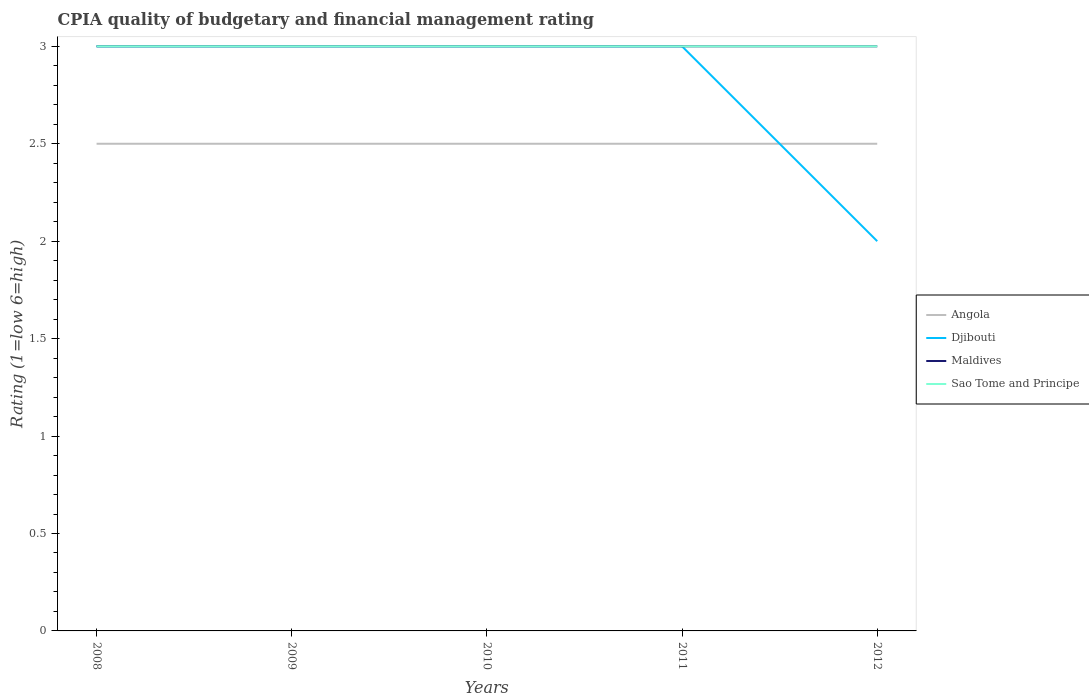How many different coloured lines are there?
Your answer should be compact. 4. Does the line corresponding to Angola intersect with the line corresponding to Maldives?
Ensure brevity in your answer.  No. Across all years, what is the maximum CPIA rating in Maldives?
Make the answer very short. 3. In which year was the CPIA rating in Djibouti maximum?
Give a very brief answer. 2012. What is the difference between the highest and the second highest CPIA rating in Maldives?
Offer a terse response. 0. Is the CPIA rating in Maldives strictly greater than the CPIA rating in Angola over the years?
Make the answer very short. No. How many lines are there?
Provide a succinct answer. 4. How many years are there in the graph?
Keep it short and to the point. 5. Does the graph contain any zero values?
Your answer should be very brief. No. What is the title of the graph?
Ensure brevity in your answer.  CPIA quality of budgetary and financial management rating. What is the Rating (1=low 6=high) in Angola in 2008?
Ensure brevity in your answer.  2.5. What is the Rating (1=low 6=high) in Djibouti in 2008?
Your answer should be compact. 3. What is the Rating (1=low 6=high) of Djibouti in 2009?
Give a very brief answer. 3. What is the Rating (1=low 6=high) in Angola in 2010?
Offer a terse response. 2.5. What is the Rating (1=low 6=high) of Djibouti in 2011?
Give a very brief answer. 3. What is the Rating (1=low 6=high) in Sao Tome and Principe in 2011?
Your answer should be compact. 3. What is the Rating (1=low 6=high) of Djibouti in 2012?
Offer a terse response. 2. Across all years, what is the maximum Rating (1=low 6=high) of Angola?
Your response must be concise. 2.5. Across all years, what is the maximum Rating (1=low 6=high) of Maldives?
Give a very brief answer. 3. Across all years, what is the minimum Rating (1=low 6=high) of Djibouti?
Ensure brevity in your answer.  2. Across all years, what is the minimum Rating (1=low 6=high) of Sao Tome and Principe?
Give a very brief answer. 3. What is the difference between the Rating (1=low 6=high) of Maldives in 2008 and that in 2009?
Give a very brief answer. 0. What is the difference between the Rating (1=low 6=high) of Sao Tome and Principe in 2008 and that in 2009?
Your answer should be very brief. 0. What is the difference between the Rating (1=low 6=high) in Angola in 2008 and that in 2010?
Make the answer very short. 0. What is the difference between the Rating (1=low 6=high) in Sao Tome and Principe in 2008 and that in 2010?
Your answer should be compact. 0. What is the difference between the Rating (1=low 6=high) in Djibouti in 2008 and that in 2011?
Offer a terse response. 0. What is the difference between the Rating (1=low 6=high) of Maldives in 2008 and that in 2011?
Your answer should be compact. 0. What is the difference between the Rating (1=low 6=high) in Sao Tome and Principe in 2008 and that in 2012?
Make the answer very short. 0. What is the difference between the Rating (1=low 6=high) in Djibouti in 2009 and that in 2010?
Make the answer very short. 0. What is the difference between the Rating (1=low 6=high) of Maldives in 2009 and that in 2010?
Provide a short and direct response. 0. What is the difference between the Rating (1=low 6=high) in Maldives in 2009 and that in 2011?
Your answer should be very brief. 0. What is the difference between the Rating (1=low 6=high) of Angola in 2009 and that in 2012?
Provide a succinct answer. 0. What is the difference between the Rating (1=low 6=high) of Maldives in 2009 and that in 2012?
Your answer should be very brief. 0. What is the difference between the Rating (1=low 6=high) in Djibouti in 2010 and that in 2011?
Give a very brief answer. 0. What is the difference between the Rating (1=low 6=high) in Maldives in 2010 and that in 2011?
Provide a succinct answer. 0. What is the difference between the Rating (1=low 6=high) in Sao Tome and Principe in 2010 and that in 2011?
Offer a very short reply. 0. What is the difference between the Rating (1=low 6=high) of Djibouti in 2010 and that in 2012?
Your answer should be very brief. 1. What is the difference between the Rating (1=low 6=high) in Maldives in 2010 and that in 2012?
Offer a very short reply. 0. What is the difference between the Rating (1=low 6=high) of Maldives in 2011 and that in 2012?
Make the answer very short. 0. What is the difference between the Rating (1=low 6=high) in Angola in 2008 and the Rating (1=low 6=high) in Djibouti in 2009?
Your answer should be very brief. -0.5. What is the difference between the Rating (1=low 6=high) in Angola in 2008 and the Rating (1=low 6=high) in Maldives in 2009?
Your answer should be very brief. -0.5. What is the difference between the Rating (1=low 6=high) in Angola in 2008 and the Rating (1=low 6=high) in Sao Tome and Principe in 2009?
Your response must be concise. -0.5. What is the difference between the Rating (1=low 6=high) of Djibouti in 2008 and the Rating (1=low 6=high) of Maldives in 2009?
Offer a terse response. 0. What is the difference between the Rating (1=low 6=high) in Angola in 2008 and the Rating (1=low 6=high) in Maldives in 2010?
Keep it short and to the point. -0.5. What is the difference between the Rating (1=low 6=high) in Djibouti in 2008 and the Rating (1=low 6=high) in Maldives in 2010?
Keep it short and to the point. 0. What is the difference between the Rating (1=low 6=high) in Djibouti in 2008 and the Rating (1=low 6=high) in Sao Tome and Principe in 2010?
Your answer should be compact. 0. What is the difference between the Rating (1=low 6=high) of Maldives in 2008 and the Rating (1=low 6=high) of Sao Tome and Principe in 2010?
Give a very brief answer. 0. What is the difference between the Rating (1=low 6=high) of Angola in 2008 and the Rating (1=low 6=high) of Djibouti in 2011?
Make the answer very short. -0.5. What is the difference between the Rating (1=low 6=high) of Angola in 2008 and the Rating (1=low 6=high) of Maldives in 2011?
Your answer should be compact. -0.5. What is the difference between the Rating (1=low 6=high) in Angola in 2008 and the Rating (1=low 6=high) in Sao Tome and Principe in 2011?
Your answer should be very brief. -0.5. What is the difference between the Rating (1=low 6=high) of Djibouti in 2008 and the Rating (1=low 6=high) of Maldives in 2011?
Your response must be concise. 0. What is the difference between the Rating (1=low 6=high) in Djibouti in 2008 and the Rating (1=low 6=high) in Sao Tome and Principe in 2011?
Your answer should be compact. 0. What is the difference between the Rating (1=low 6=high) in Maldives in 2008 and the Rating (1=low 6=high) in Sao Tome and Principe in 2011?
Give a very brief answer. 0. What is the difference between the Rating (1=low 6=high) in Angola in 2008 and the Rating (1=low 6=high) in Djibouti in 2012?
Offer a very short reply. 0.5. What is the difference between the Rating (1=low 6=high) in Angola in 2008 and the Rating (1=low 6=high) in Maldives in 2012?
Provide a short and direct response. -0.5. What is the difference between the Rating (1=low 6=high) in Angola in 2009 and the Rating (1=low 6=high) in Djibouti in 2010?
Provide a succinct answer. -0.5. What is the difference between the Rating (1=low 6=high) in Angola in 2009 and the Rating (1=low 6=high) in Maldives in 2010?
Provide a short and direct response. -0.5. What is the difference between the Rating (1=low 6=high) in Angola in 2009 and the Rating (1=low 6=high) in Sao Tome and Principe in 2011?
Offer a terse response. -0.5. What is the difference between the Rating (1=low 6=high) in Djibouti in 2009 and the Rating (1=low 6=high) in Maldives in 2011?
Your response must be concise. 0. What is the difference between the Rating (1=low 6=high) in Djibouti in 2009 and the Rating (1=low 6=high) in Sao Tome and Principe in 2011?
Keep it short and to the point. 0. What is the difference between the Rating (1=low 6=high) in Angola in 2009 and the Rating (1=low 6=high) in Djibouti in 2012?
Your response must be concise. 0.5. What is the difference between the Rating (1=low 6=high) of Angola in 2009 and the Rating (1=low 6=high) of Maldives in 2012?
Your response must be concise. -0.5. What is the difference between the Rating (1=low 6=high) in Angola in 2009 and the Rating (1=low 6=high) in Sao Tome and Principe in 2012?
Offer a very short reply. -0.5. What is the difference between the Rating (1=low 6=high) in Angola in 2010 and the Rating (1=low 6=high) in Djibouti in 2011?
Offer a very short reply. -0.5. What is the difference between the Rating (1=low 6=high) in Djibouti in 2010 and the Rating (1=low 6=high) in Maldives in 2011?
Make the answer very short. 0. What is the difference between the Rating (1=low 6=high) of Angola in 2010 and the Rating (1=low 6=high) of Djibouti in 2012?
Make the answer very short. 0.5. What is the difference between the Rating (1=low 6=high) of Angola in 2010 and the Rating (1=low 6=high) of Maldives in 2012?
Your answer should be compact. -0.5. What is the difference between the Rating (1=low 6=high) in Angola in 2010 and the Rating (1=low 6=high) in Sao Tome and Principe in 2012?
Offer a very short reply. -0.5. What is the difference between the Rating (1=low 6=high) of Djibouti in 2010 and the Rating (1=low 6=high) of Sao Tome and Principe in 2012?
Offer a very short reply. 0. What is the difference between the Rating (1=low 6=high) in Angola in 2011 and the Rating (1=low 6=high) in Djibouti in 2012?
Offer a very short reply. 0.5. What is the difference between the Rating (1=low 6=high) of Angola in 2011 and the Rating (1=low 6=high) of Maldives in 2012?
Provide a succinct answer. -0.5. What is the difference between the Rating (1=low 6=high) of Maldives in 2011 and the Rating (1=low 6=high) of Sao Tome and Principe in 2012?
Provide a short and direct response. 0. What is the average Rating (1=low 6=high) in Angola per year?
Give a very brief answer. 2.5. What is the average Rating (1=low 6=high) of Maldives per year?
Your answer should be compact. 3. What is the average Rating (1=low 6=high) of Sao Tome and Principe per year?
Offer a terse response. 3. In the year 2008, what is the difference between the Rating (1=low 6=high) in Angola and Rating (1=low 6=high) in Maldives?
Make the answer very short. -0.5. In the year 2008, what is the difference between the Rating (1=low 6=high) in Maldives and Rating (1=low 6=high) in Sao Tome and Principe?
Make the answer very short. 0. In the year 2009, what is the difference between the Rating (1=low 6=high) of Angola and Rating (1=low 6=high) of Djibouti?
Offer a terse response. -0.5. In the year 2009, what is the difference between the Rating (1=low 6=high) of Angola and Rating (1=low 6=high) of Maldives?
Ensure brevity in your answer.  -0.5. In the year 2009, what is the difference between the Rating (1=low 6=high) of Djibouti and Rating (1=low 6=high) of Sao Tome and Principe?
Offer a very short reply. 0. In the year 2009, what is the difference between the Rating (1=low 6=high) of Maldives and Rating (1=low 6=high) of Sao Tome and Principe?
Your answer should be compact. 0. In the year 2010, what is the difference between the Rating (1=low 6=high) of Angola and Rating (1=low 6=high) of Djibouti?
Your answer should be very brief. -0.5. In the year 2010, what is the difference between the Rating (1=low 6=high) in Angola and Rating (1=low 6=high) in Maldives?
Your answer should be compact. -0.5. In the year 2010, what is the difference between the Rating (1=low 6=high) of Angola and Rating (1=low 6=high) of Sao Tome and Principe?
Offer a very short reply. -0.5. In the year 2011, what is the difference between the Rating (1=low 6=high) of Angola and Rating (1=low 6=high) of Maldives?
Provide a succinct answer. -0.5. In the year 2011, what is the difference between the Rating (1=low 6=high) in Angola and Rating (1=low 6=high) in Sao Tome and Principe?
Your answer should be very brief. -0.5. In the year 2011, what is the difference between the Rating (1=low 6=high) of Djibouti and Rating (1=low 6=high) of Maldives?
Give a very brief answer. 0. In the year 2011, what is the difference between the Rating (1=low 6=high) in Djibouti and Rating (1=low 6=high) in Sao Tome and Principe?
Provide a short and direct response. 0. In the year 2011, what is the difference between the Rating (1=low 6=high) in Maldives and Rating (1=low 6=high) in Sao Tome and Principe?
Offer a terse response. 0. In the year 2012, what is the difference between the Rating (1=low 6=high) of Angola and Rating (1=low 6=high) of Djibouti?
Keep it short and to the point. 0.5. In the year 2012, what is the difference between the Rating (1=low 6=high) in Angola and Rating (1=low 6=high) in Maldives?
Offer a terse response. -0.5. In the year 2012, what is the difference between the Rating (1=low 6=high) of Angola and Rating (1=low 6=high) of Sao Tome and Principe?
Your answer should be very brief. -0.5. In the year 2012, what is the difference between the Rating (1=low 6=high) of Maldives and Rating (1=low 6=high) of Sao Tome and Principe?
Your response must be concise. 0. What is the ratio of the Rating (1=low 6=high) in Djibouti in 2008 to that in 2009?
Your answer should be compact. 1. What is the ratio of the Rating (1=low 6=high) in Angola in 2008 to that in 2010?
Ensure brevity in your answer.  1. What is the ratio of the Rating (1=low 6=high) in Maldives in 2008 to that in 2010?
Offer a very short reply. 1. What is the ratio of the Rating (1=low 6=high) of Angola in 2009 to that in 2010?
Provide a succinct answer. 1. What is the ratio of the Rating (1=low 6=high) of Maldives in 2009 to that in 2010?
Give a very brief answer. 1. What is the ratio of the Rating (1=low 6=high) in Angola in 2009 to that in 2011?
Keep it short and to the point. 1. What is the ratio of the Rating (1=low 6=high) of Djibouti in 2009 to that in 2011?
Offer a terse response. 1. What is the ratio of the Rating (1=low 6=high) in Angola in 2009 to that in 2012?
Keep it short and to the point. 1. What is the ratio of the Rating (1=low 6=high) in Djibouti in 2009 to that in 2012?
Provide a succinct answer. 1.5. What is the ratio of the Rating (1=low 6=high) of Maldives in 2009 to that in 2012?
Provide a short and direct response. 1. What is the ratio of the Rating (1=low 6=high) in Sao Tome and Principe in 2009 to that in 2012?
Make the answer very short. 1. What is the ratio of the Rating (1=low 6=high) of Angola in 2010 to that in 2011?
Make the answer very short. 1. What is the ratio of the Rating (1=low 6=high) in Djibouti in 2010 to that in 2011?
Offer a terse response. 1. What is the ratio of the Rating (1=low 6=high) of Maldives in 2010 to that in 2011?
Make the answer very short. 1. What is the ratio of the Rating (1=low 6=high) of Sao Tome and Principe in 2010 to that in 2011?
Provide a short and direct response. 1. What is the ratio of the Rating (1=low 6=high) in Maldives in 2010 to that in 2012?
Your answer should be compact. 1. What is the ratio of the Rating (1=low 6=high) of Djibouti in 2011 to that in 2012?
Your answer should be very brief. 1.5. What is the difference between the highest and the second highest Rating (1=low 6=high) in Djibouti?
Offer a very short reply. 0. What is the difference between the highest and the second highest Rating (1=low 6=high) of Sao Tome and Principe?
Make the answer very short. 0. What is the difference between the highest and the lowest Rating (1=low 6=high) of Angola?
Make the answer very short. 0. What is the difference between the highest and the lowest Rating (1=low 6=high) in Sao Tome and Principe?
Your response must be concise. 0. 